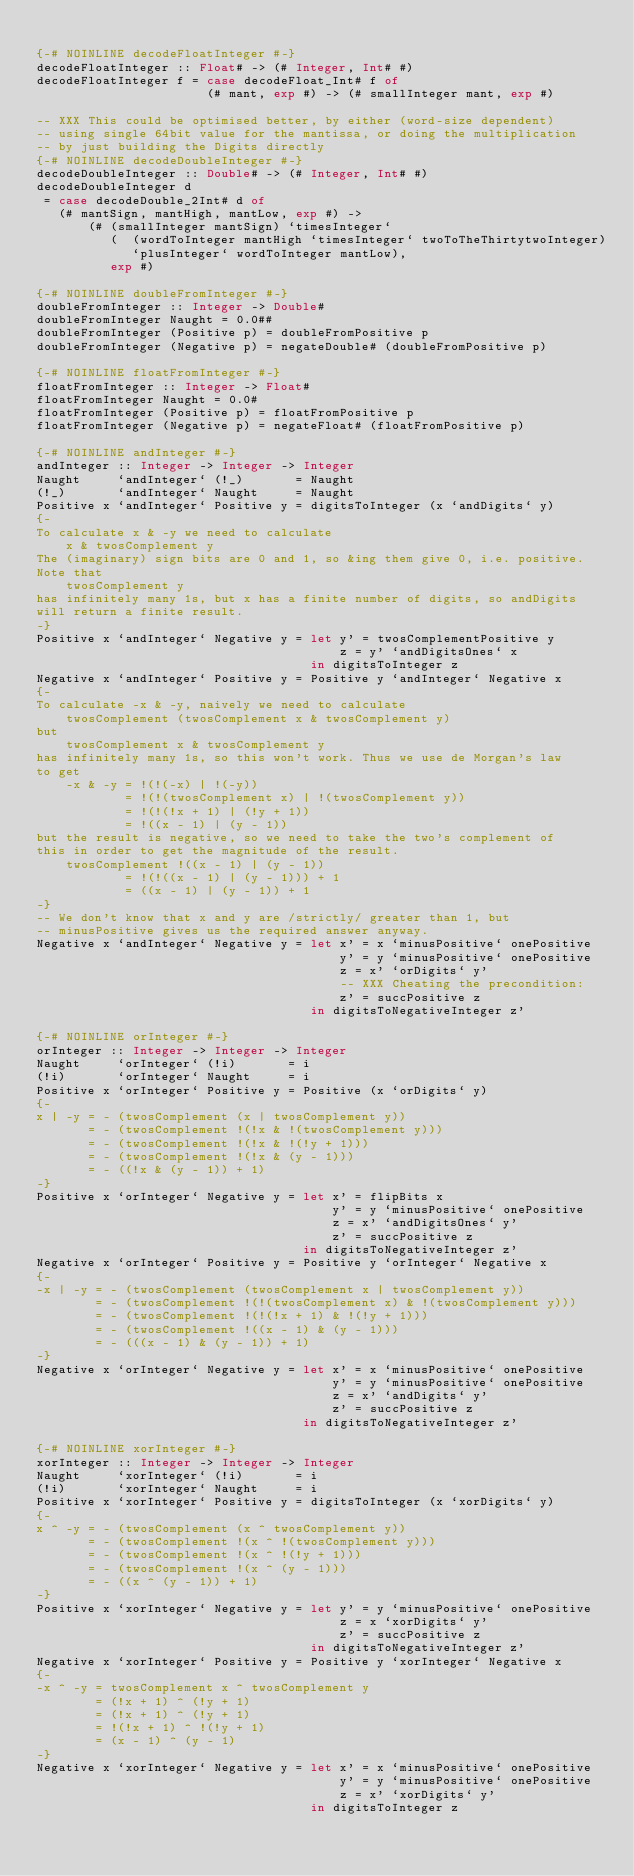Convert code to text. <code><loc_0><loc_0><loc_500><loc_500><_Haskell_>
{-# NOINLINE decodeFloatInteger #-}
decodeFloatInteger :: Float# -> (# Integer, Int# #)
decodeFloatInteger f = case decodeFloat_Int# f of
                       (# mant, exp #) -> (# smallInteger mant, exp #)

-- XXX This could be optimised better, by either (word-size dependent)
-- using single 64bit value for the mantissa, or doing the multiplication
-- by just building the Digits directly
{-# NOINLINE decodeDoubleInteger #-}
decodeDoubleInteger :: Double# -> (# Integer, Int# #)
decodeDoubleInteger d
 = case decodeDouble_2Int# d of
   (# mantSign, mantHigh, mantLow, exp #) ->
       (# (smallInteger mantSign) `timesInteger`
          (  (wordToInteger mantHigh `timesInteger` twoToTheThirtytwoInteger)
             `plusInteger` wordToInteger mantLow),
          exp #)

{-# NOINLINE doubleFromInteger #-}
doubleFromInteger :: Integer -> Double#
doubleFromInteger Naught = 0.0##
doubleFromInteger (Positive p) = doubleFromPositive p
doubleFromInteger (Negative p) = negateDouble# (doubleFromPositive p)

{-# NOINLINE floatFromInteger #-}
floatFromInteger :: Integer -> Float#
floatFromInteger Naught = 0.0#
floatFromInteger (Positive p) = floatFromPositive p
floatFromInteger (Negative p) = negateFloat# (floatFromPositive p)

{-# NOINLINE andInteger #-}
andInteger :: Integer -> Integer -> Integer
Naught     `andInteger` (!_)       = Naught
(!_)       `andInteger` Naught     = Naught
Positive x `andInteger` Positive y = digitsToInteger (x `andDigits` y)
{-
To calculate x & -y we need to calculate
    x & twosComplement y
The (imaginary) sign bits are 0 and 1, so &ing them give 0, i.e. positive.
Note that
    twosComplement y
has infinitely many 1s, but x has a finite number of digits, so andDigits
will return a finite result.
-}
Positive x `andInteger` Negative y = let y' = twosComplementPositive y
                                         z = y' `andDigitsOnes` x
                                     in digitsToInteger z
Negative x `andInteger` Positive y = Positive y `andInteger` Negative x
{-
To calculate -x & -y, naively we need to calculate
    twosComplement (twosComplement x & twosComplement y)
but
    twosComplement x & twosComplement y
has infinitely many 1s, so this won't work. Thus we use de Morgan's law
to get
    -x & -y = !(!(-x) | !(-y))
            = !(!(twosComplement x) | !(twosComplement y))
            = !(!(!x + 1) | (!y + 1))
            = !((x - 1) | (y - 1))
but the result is negative, so we need to take the two's complement of
this in order to get the magnitude of the result.
    twosComplement !((x - 1) | (y - 1))
            = !(!((x - 1) | (y - 1))) + 1
            = ((x - 1) | (y - 1)) + 1
-}
-- We don't know that x and y are /strictly/ greater than 1, but
-- minusPositive gives us the required answer anyway.
Negative x `andInteger` Negative y = let x' = x `minusPositive` onePositive
                                         y' = y `minusPositive` onePositive
                                         z = x' `orDigits` y'
                                         -- XXX Cheating the precondition:
                                         z' = succPositive z
                                     in digitsToNegativeInteger z'

{-# NOINLINE orInteger #-}
orInteger :: Integer -> Integer -> Integer
Naught     `orInteger` (!i)       = i
(!i)       `orInteger` Naught     = i
Positive x `orInteger` Positive y = Positive (x `orDigits` y)
{-
x | -y = - (twosComplement (x | twosComplement y))
       = - (twosComplement !(!x & !(twosComplement y)))
       = - (twosComplement !(!x & !(!y + 1)))
       = - (twosComplement !(!x & (y - 1)))
       = - ((!x & (y - 1)) + 1)
-}
Positive x `orInteger` Negative y = let x' = flipBits x
                                        y' = y `minusPositive` onePositive
                                        z = x' `andDigitsOnes` y'
                                        z' = succPositive z
                                    in digitsToNegativeInteger z'
Negative x `orInteger` Positive y = Positive y `orInteger` Negative x
{-
-x | -y = - (twosComplement (twosComplement x | twosComplement y))
        = - (twosComplement !(!(twosComplement x) & !(twosComplement y)))
        = - (twosComplement !(!(!x + 1) & !(!y + 1)))
        = - (twosComplement !((x - 1) & (y - 1)))
        = - (((x - 1) & (y - 1)) + 1)
-}
Negative x `orInteger` Negative y = let x' = x `minusPositive` onePositive
                                        y' = y `minusPositive` onePositive
                                        z = x' `andDigits` y'
                                        z' = succPositive z
                                    in digitsToNegativeInteger z'

{-# NOINLINE xorInteger #-}
xorInteger :: Integer -> Integer -> Integer
Naught     `xorInteger` (!i)       = i
(!i)       `xorInteger` Naught     = i
Positive x `xorInteger` Positive y = digitsToInteger (x `xorDigits` y)
{-
x ^ -y = - (twosComplement (x ^ twosComplement y))
       = - (twosComplement !(x ^ !(twosComplement y)))
       = - (twosComplement !(x ^ !(!y + 1)))
       = - (twosComplement !(x ^ (y - 1)))
       = - ((x ^ (y - 1)) + 1)
-}
Positive x `xorInteger` Negative y = let y' = y `minusPositive` onePositive
                                         z = x `xorDigits` y'
                                         z' = succPositive z
                                     in digitsToNegativeInteger z'
Negative x `xorInteger` Positive y = Positive y `xorInteger` Negative x
{-
-x ^ -y = twosComplement x ^ twosComplement y
        = (!x + 1) ^ (!y + 1)
        = (!x + 1) ^ (!y + 1)
        = !(!x + 1) ^ !(!y + 1)
        = (x - 1) ^ (y - 1)
-}
Negative x `xorInteger` Negative y = let x' = x `minusPositive` onePositive
                                         y' = y `minusPositive` onePositive
                                         z = x' `xorDigits` y'
                                     in digitsToInteger z
</code> 